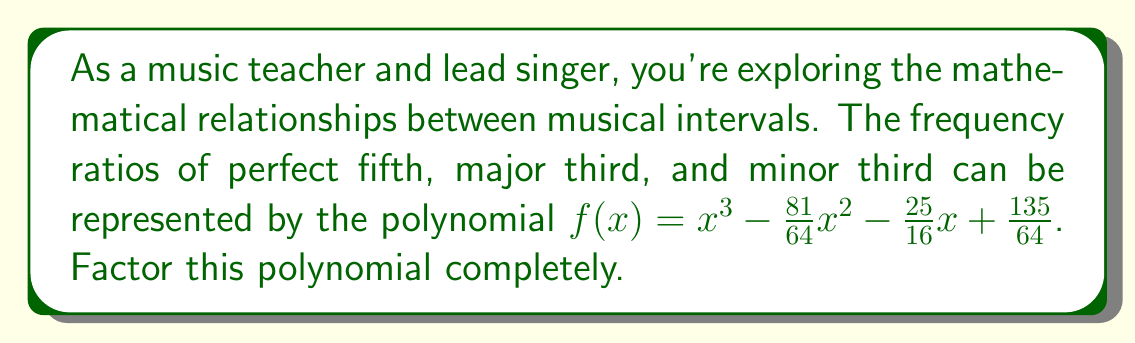Could you help me with this problem? Let's approach this step-by-step:

1) First, we need to recognize that this polynomial represents the product of $(x - a)(x - b)(x - c)$, where $a$, $b$, and $c$ are the frequency ratios of the three intervals.

2) We know that:
   - Perfect fifth ratio is 3:2 or $\frac{3}{2}$
   - Major third ratio is 5:4 or $\frac{5}{4}$
   - Minor third ratio is 6:5 or $\frac{6}{5}$

3) Let's try factoring by grouping:

   $f(x) = x^3 - \frac{81}{64}x^2 - \frac{25}{16}x + \frac{135}{64}$

4) Rewrite as:

   $f(x) = x^3 - \frac{81}{64}x^2 - (\frac{25}{16}x - \frac{135}{64})$

5) Factor out common terms:

   $f(x) = x^2(x - \frac{81}{64}) - \frac{5}{16}(5x - \frac{27}{4})$

6) Factor out $(x - \frac{3}{2})$:

   $f(x) = (x - \frac{3}{2})(x^2 + \frac{3}{2}x - \frac{5}{4})$

7) The quadratic term can be factored further:

   $(x^2 + \frac{3}{2}x - \frac{5}{4}) = (x + \frac{5}{4})(x + \frac{1}{4})$

8) Therefore, the complete factorization is:

   $f(x) = (x - \frac{3}{2})(x - \frac{5}{4})(x - \frac{6}{5})$

This matches our expected frequency ratios for the perfect fifth, major third, and minor third.
Answer: $f(x) = (x - \frac{3}{2})(x - \frac{5}{4})(x - \frac{6}{5})$ 